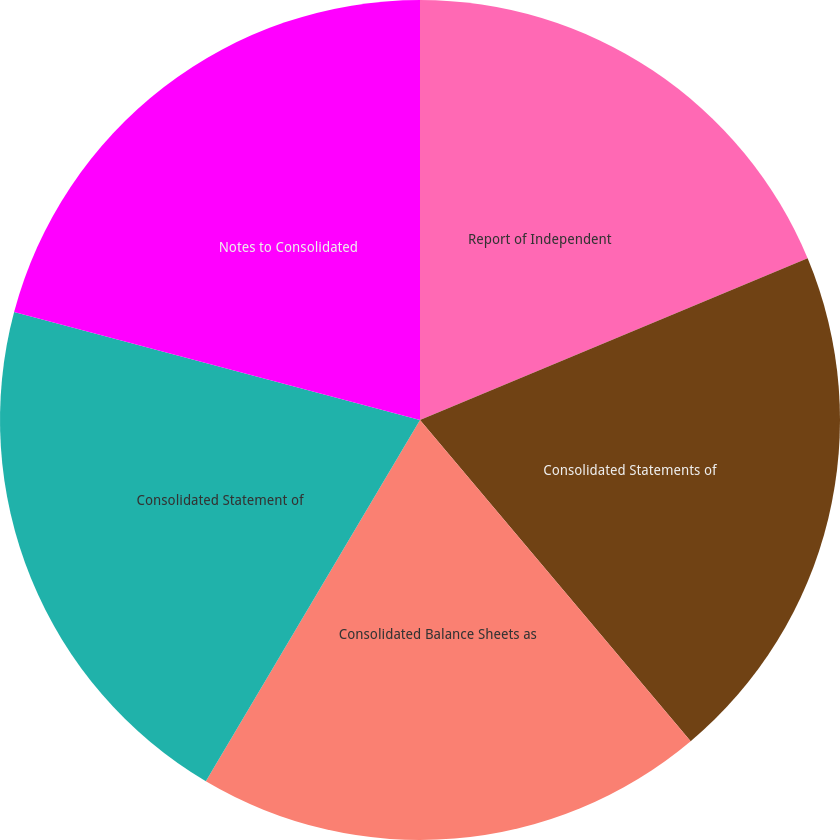<chart> <loc_0><loc_0><loc_500><loc_500><pie_chart><fcel>Report of Independent<fcel>Consolidated Statements of<fcel>Consolidated Balance Sheets as<fcel>Consolidated Statement of<fcel>Notes to Consolidated<nl><fcel>18.71%<fcel>20.14%<fcel>19.66%<fcel>20.62%<fcel>20.86%<nl></chart> 